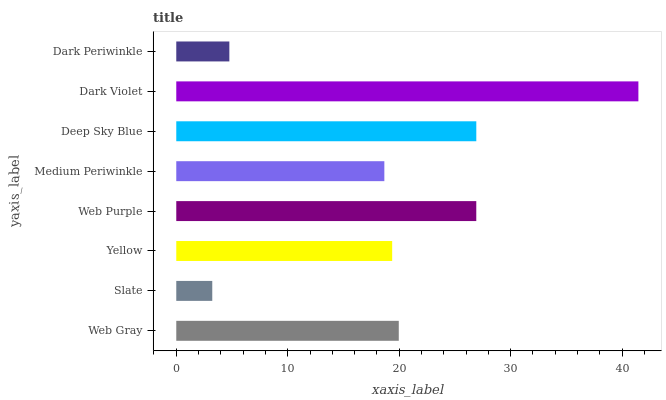Is Slate the minimum?
Answer yes or no. Yes. Is Dark Violet the maximum?
Answer yes or no. Yes. Is Yellow the minimum?
Answer yes or no. No. Is Yellow the maximum?
Answer yes or no. No. Is Yellow greater than Slate?
Answer yes or no. Yes. Is Slate less than Yellow?
Answer yes or no. Yes. Is Slate greater than Yellow?
Answer yes or no. No. Is Yellow less than Slate?
Answer yes or no. No. Is Web Gray the high median?
Answer yes or no. Yes. Is Yellow the low median?
Answer yes or no. Yes. Is Dark Violet the high median?
Answer yes or no. No. Is Dark Periwinkle the low median?
Answer yes or no. No. 